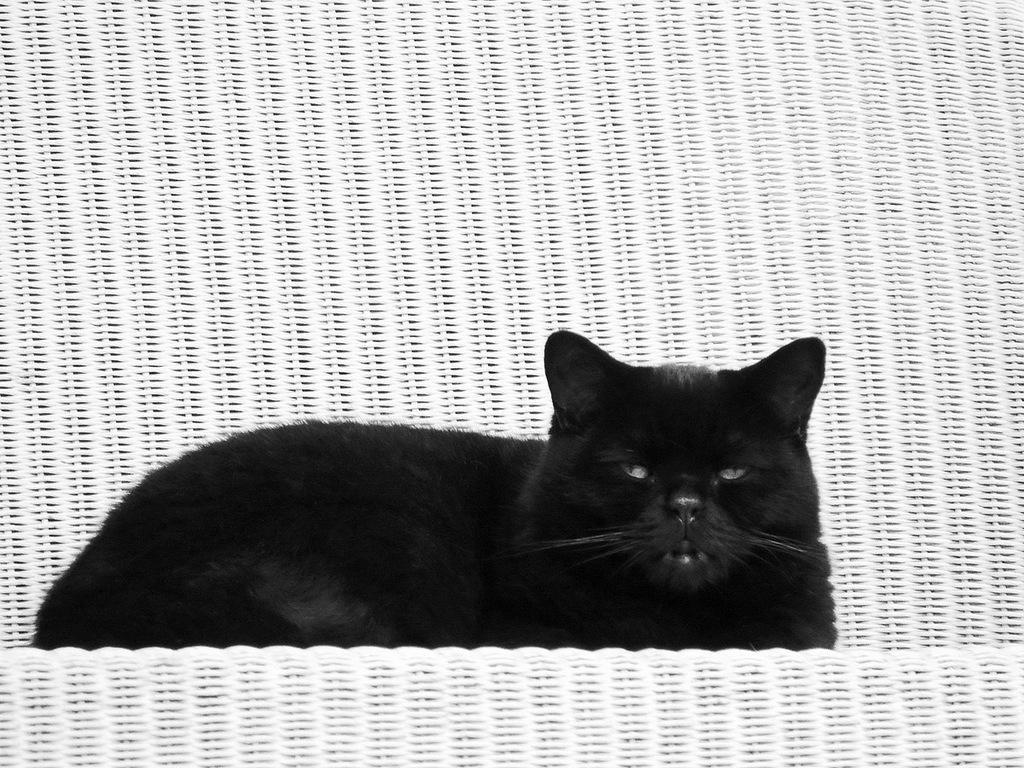Describe this image in one or two sentences. In this picture there is a black color cat sitting in a white chair. 